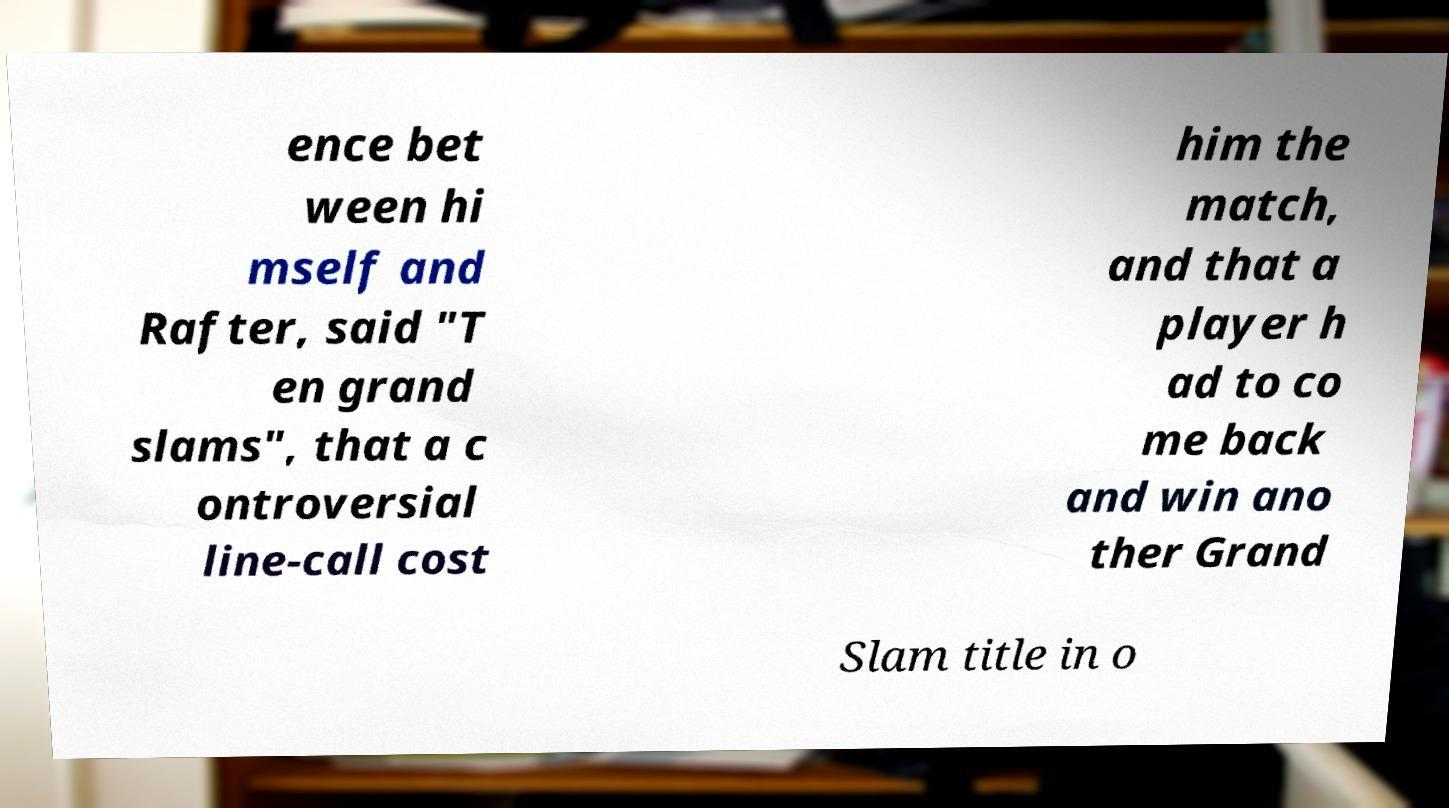For documentation purposes, I need the text within this image transcribed. Could you provide that? ence bet ween hi mself and Rafter, said "T en grand slams", that a c ontroversial line-call cost him the match, and that a player h ad to co me back and win ano ther Grand Slam title in o 